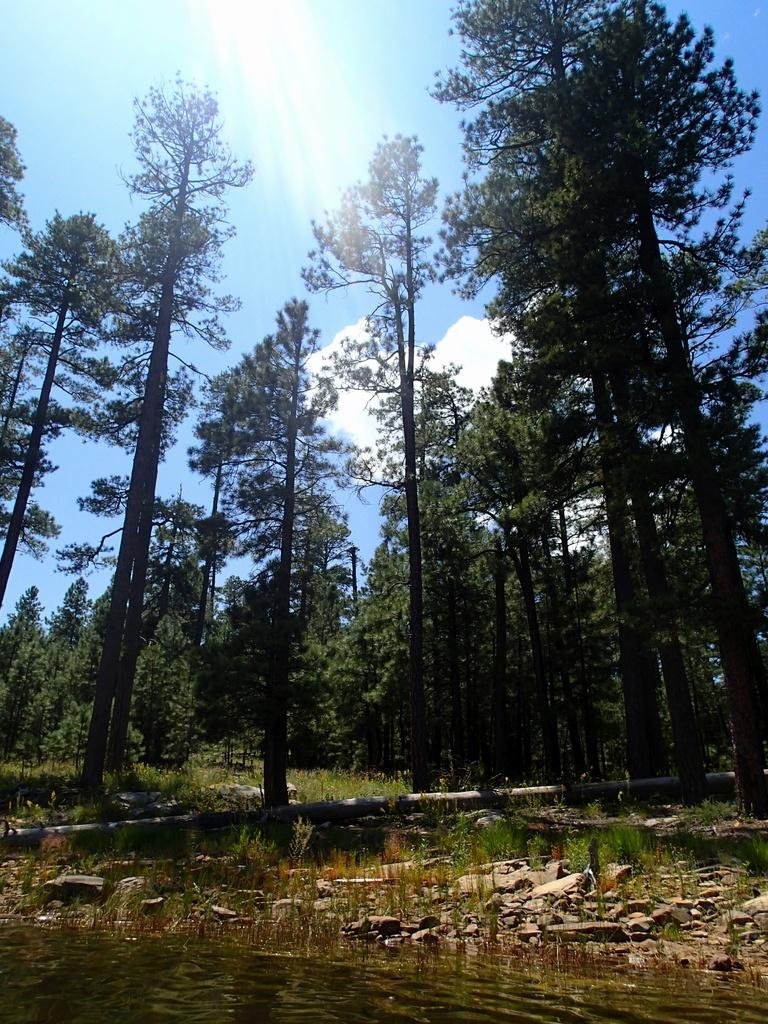What is located in the center of the image? There are trees in the center of the image. What can be seen at the bottom of the image? There is a pond, rocks, and grass at the bottom of the image. What is visible at the top of the image? The sky is visible at the top of the image. Can you read the list of ingredients for the grass in the image? There is no list of ingredients for the grass in the image, as it is a natural element and not a product. How does the pond breathe in the image? The pond does not breathe in the image, as it is a body of water and not a living organism. 